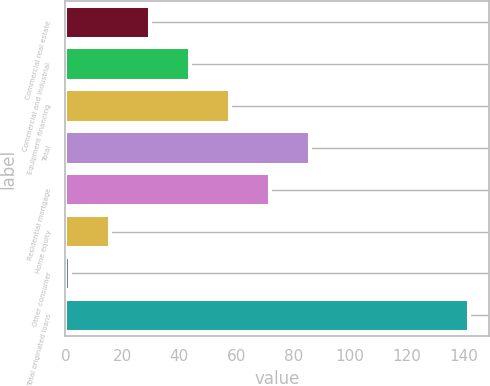Convert chart. <chart><loc_0><loc_0><loc_500><loc_500><bar_chart><fcel>Commercial real estate<fcel>Commercial and industrial<fcel>Equipment financing<fcel>Total<fcel>Residential mortgage<fcel>Home equity<fcel>Other consumer<fcel>Total originated loans<nl><fcel>29.72<fcel>43.73<fcel>57.74<fcel>85.76<fcel>71.75<fcel>15.71<fcel>1.7<fcel>141.8<nl></chart> 